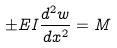Convert formula to latex. <formula><loc_0><loc_0><loc_500><loc_500>\pm E I \frac { d ^ { 2 } w } { d x ^ { 2 } } = M</formula> 